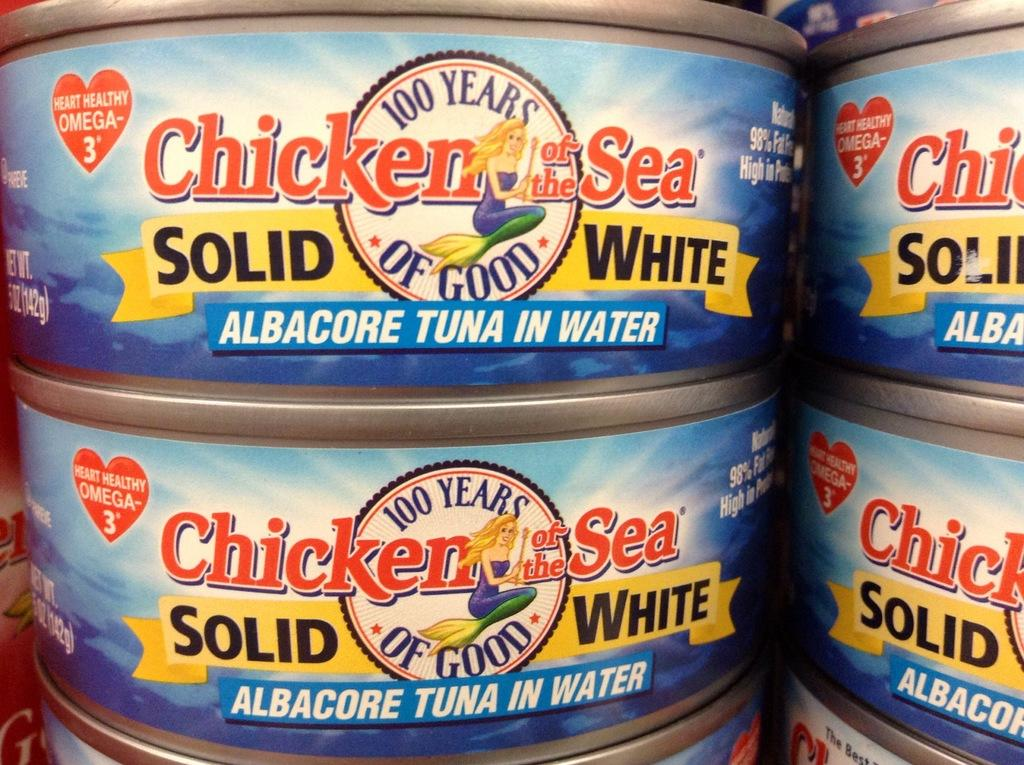What objects are present in the image? There are tins in the image. What is written or printed on the tins? The tins have alphabets and numbers on them. How many sisters are depicted on the tins in the image? There are no sisters depicted on the tins in the image; the tins have alphabets and numbers on them. 